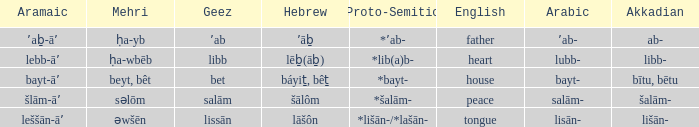If the geez is libb, what is the akkadian? Libb-. 